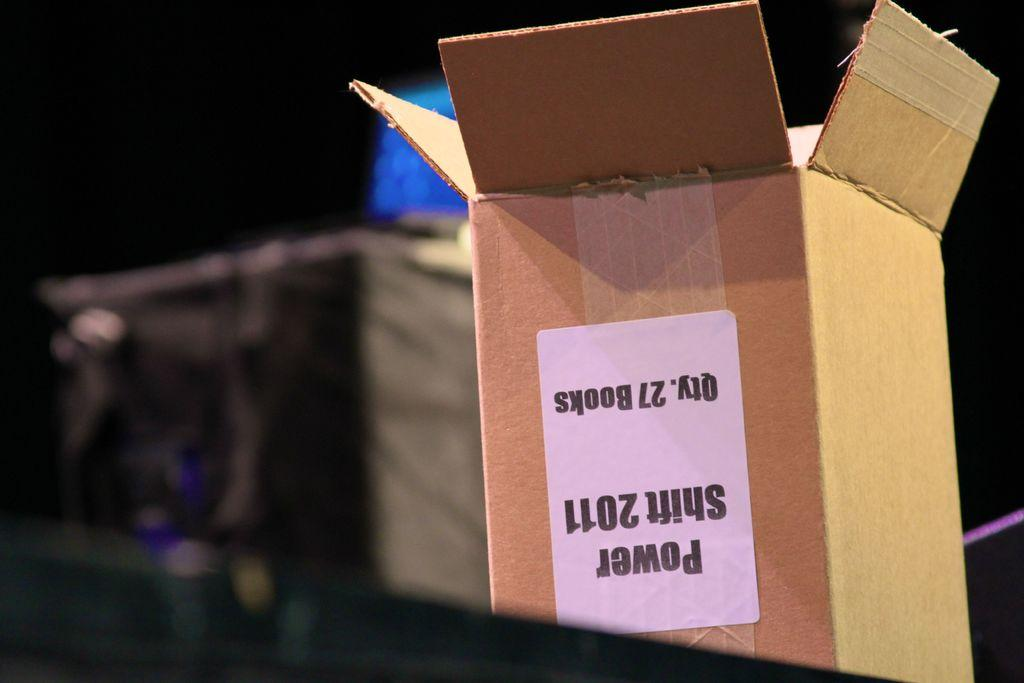<image>
Write a terse but informative summary of the picture. A cardboard box with a label reading Power Shift 2011. 